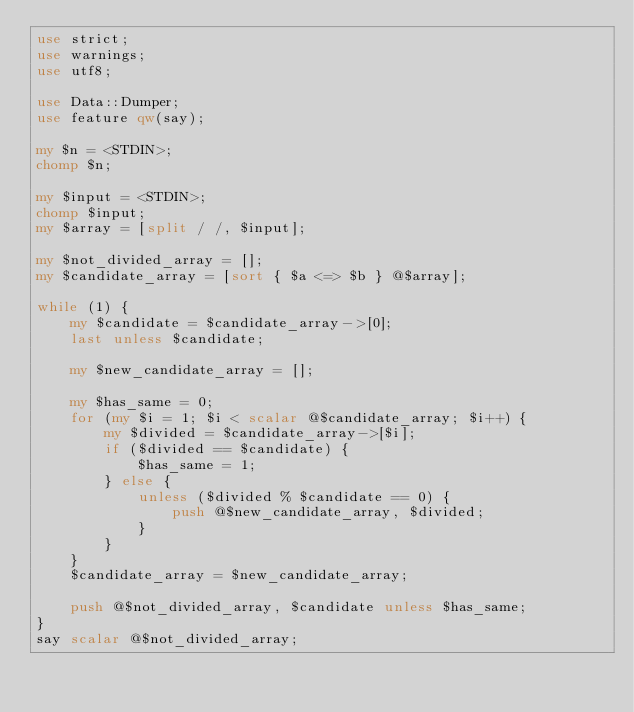<code> <loc_0><loc_0><loc_500><loc_500><_Perl_>use strict;
use warnings;
use utf8;

use Data::Dumper;
use feature qw(say);

my $n = <STDIN>;
chomp $n;

my $input = <STDIN>;
chomp $input;
my $array = [split / /, $input];

my $not_divided_array = [];
my $candidate_array = [sort { $a <=> $b } @$array];

while (1) {
    my $candidate = $candidate_array->[0];
    last unless $candidate;

    my $new_candidate_array = [];

    my $has_same = 0;
    for (my $i = 1; $i < scalar @$candidate_array; $i++) {
        my $divided = $candidate_array->[$i];
        if ($divided == $candidate) {
            $has_same = 1;
        } else {
            unless ($divided % $candidate == 0) {
                push @$new_candidate_array, $divided;
            }
        }
    }
    $candidate_array = $new_candidate_array;

    push @$not_divided_array, $candidate unless $has_same;
}
say scalar @$not_divided_array;</code> 